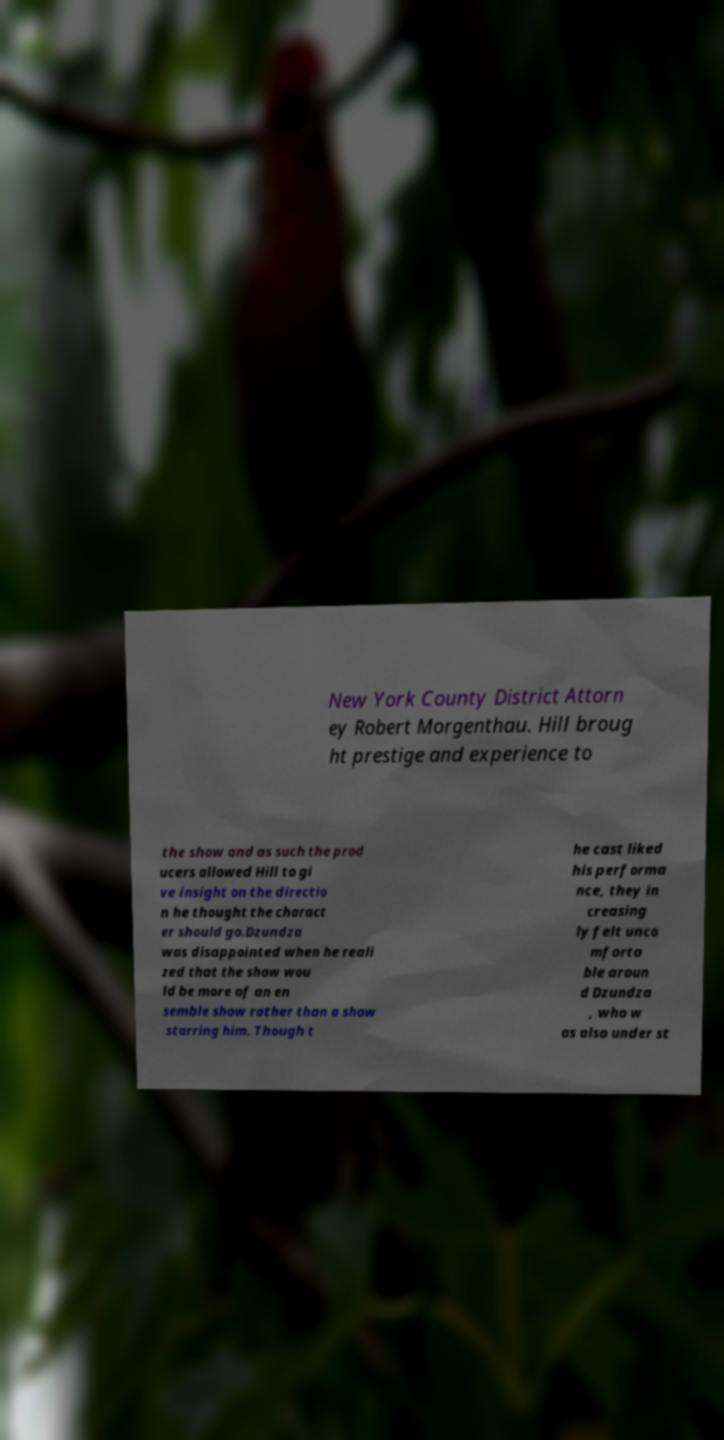For documentation purposes, I need the text within this image transcribed. Could you provide that? New York County District Attorn ey Robert Morgenthau. Hill broug ht prestige and experience to the show and as such the prod ucers allowed Hill to gi ve insight on the directio n he thought the charact er should go.Dzundza was disappointed when he reali zed that the show wou ld be more of an en semble show rather than a show starring him. Though t he cast liked his performa nce, they in creasing ly felt unco mforta ble aroun d Dzundza , who w as also under st 